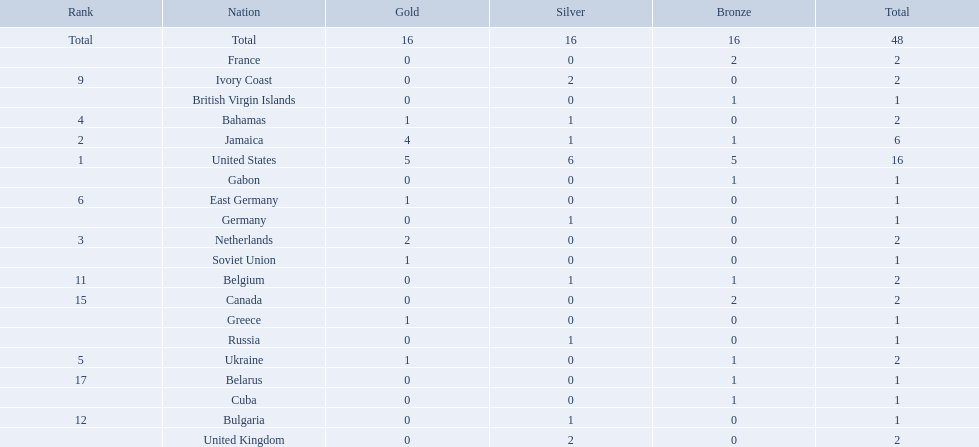Which countries competed in the 60 meters competition? United States, Jamaica, Netherlands, Bahamas, Ukraine, East Germany, Greece, Soviet Union, Ivory Coast, United Kingdom, Belgium, Bulgaria, Russia, Germany, Canada, France, Belarus, Cuba, Gabon, British Virgin Islands. And how many gold medals did they win? 5, 4, 2, 1, 1, 1, 1, 1, 0, 0, 0, 0, 0, 0, 0, 0, 0, 0, 0, 0. Of those countries, which won the second highest number gold medals? Jamaica. 